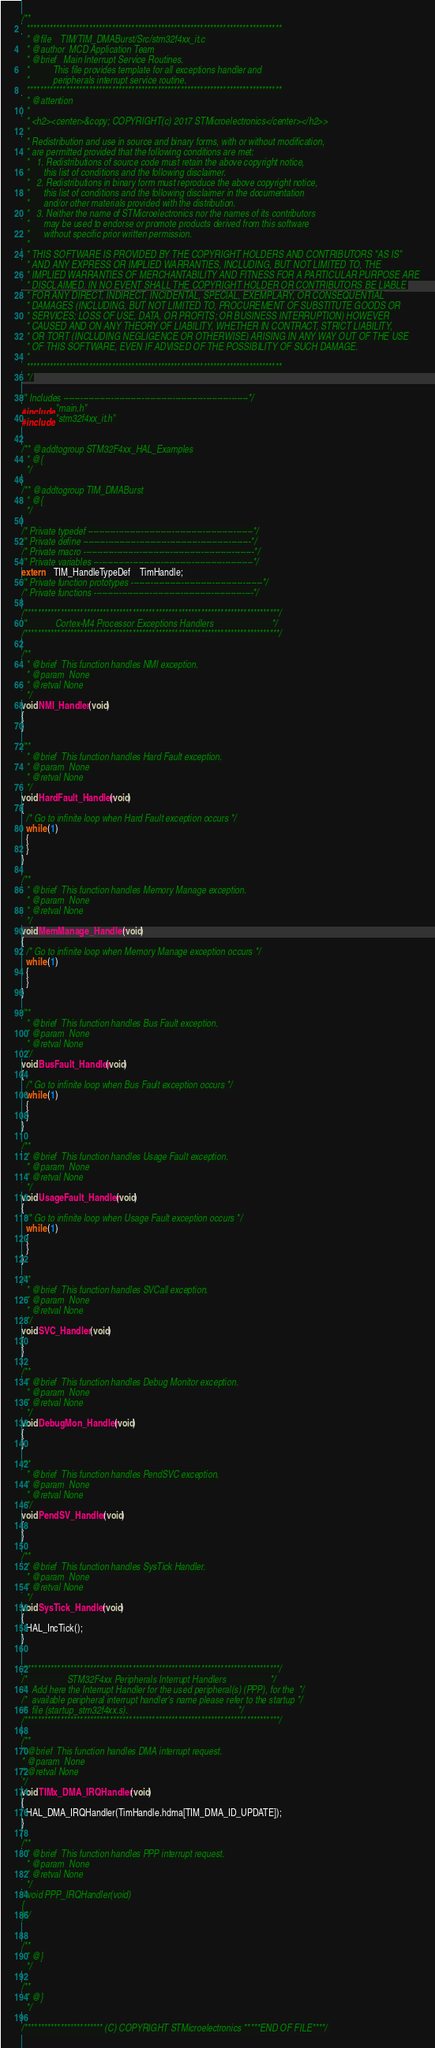Convert code to text. <code><loc_0><loc_0><loc_500><loc_500><_C_>/**
  ******************************************************************************
  * @file    TIM/TIM_DMABurst/Src/stm32f4xx_it.c  
  * @author  MCD Application Team
  * @brief   Main Interrupt Service Routines.
  *          This file provides template for all exceptions handler and 
  *          peripherals interrupt service routine.
  ******************************************************************************
  * @attention
  *
  * <h2><center>&copy; COPYRIGHT(c) 2017 STMicroelectronics</center></h2>>
  *
  * Redistribution and use in source and binary forms, with or without modification,
  * are permitted provided that the following conditions are met:
  *   1. Redistributions of source code must retain the above copyright notice,
  *      this list of conditions and the following disclaimer.
  *   2. Redistributions in binary form must reproduce the above copyright notice,
  *      this list of conditions and the following disclaimer in the documentation
  *      and/or other materials provided with the distribution.
  *   3. Neither the name of STMicroelectronics nor the names of its contributors
  *      may be used to endorse or promote products derived from this software
  *      without specific prior written permission.
  *
  * THIS SOFTWARE IS PROVIDED BY THE COPYRIGHT HOLDERS AND CONTRIBUTORS "AS IS"
  * AND ANY EXPRESS OR IMPLIED WARRANTIES, INCLUDING, BUT NOT LIMITED TO, THE
  * IMPLIED WARRANTIES OF MERCHANTABILITY AND FITNESS FOR A PARTICULAR PURPOSE ARE
  * DISCLAIMED. IN NO EVENT SHALL THE COPYRIGHT HOLDER OR CONTRIBUTORS BE LIABLE
  * FOR ANY DIRECT, INDIRECT, INCIDENTAL, SPECIAL, EXEMPLARY, OR CONSEQUENTIAL
  * DAMAGES (INCLUDING, BUT NOT LIMITED TO, PROCUREMENT OF SUBSTITUTE GOODS OR
  * SERVICES; LOSS OF USE, DATA, OR PROFITS; OR BUSINESS INTERRUPTION) HOWEVER
  * CAUSED AND ON ANY THEORY OF LIABILITY, WHETHER IN CONTRACT, STRICT LIABILITY,
  * OR TORT (INCLUDING NEGLIGENCE OR OTHERWISE) ARISING IN ANY WAY OUT OF THE USE
  * OF THIS SOFTWARE, EVEN IF ADVISED OF THE POSSIBILITY OF SUCH DAMAGE.
  *
  ******************************************************************************
  */

/* Includes ------------------------------------------------------------------*/
#include "main.h"
#include "stm32f4xx_it.h"
   

/** @addtogroup STM32F4xx_HAL_Examples
  * @{
  */

/** @addtogroup TIM_DMABurst
  * @{
  */

/* Private typedef -----------------------------------------------------------*/
/* Private define ------------------------------------------------------------*/
/* Private macro -------------------------------------------------------------*/
/* Private variables ---------------------------------------------------------*/
extern    TIM_HandleTypeDef    TimHandle;    
/* Private function prototypes -----------------------------------------------*/
/* Private functions ---------------------------------------------------------*/

/******************************************************************************/
/*            Cortex-M4 Processor Exceptions Handlers                         */
/******************************************************************************/

/**
  * @brief  This function handles NMI exception.
  * @param  None
  * @retval None
  */
void NMI_Handler(void)
{
}

/**
  * @brief  This function handles Hard Fault exception.
  * @param  None
  * @retval None
  */
void HardFault_Handler(void)
{
  /* Go to infinite loop when Hard Fault exception occurs */
  while (1)
  {
  }
}

/**
  * @brief  This function handles Memory Manage exception.
  * @param  None
  * @retval None
  */
void MemManage_Handler(void)
{
  /* Go to infinite loop when Memory Manage exception occurs */
  while (1)
  {
  }
}

/**
  * @brief  This function handles Bus Fault exception.
  * @param  None
  * @retval None
  */
void BusFault_Handler(void)
{
  /* Go to infinite loop when Bus Fault exception occurs */
  while (1)
  {
  }
}

/**
  * @brief  This function handles Usage Fault exception.
  * @param  None
  * @retval None
  */
void UsageFault_Handler(void)
{
  /* Go to infinite loop when Usage Fault exception occurs */
  while (1)
  {
  }
}

/**
  * @brief  This function handles SVCall exception.
  * @param  None
  * @retval None
  */
void SVC_Handler(void)
{
}

/**
  * @brief  This function handles Debug Monitor exception.
  * @param  None
  * @retval None
  */
void DebugMon_Handler(void)
{
}

/**
  * @brief  This function handles PendSVC exception.
  * @param  None
  * @retval None
  */
void PendSV_Handler(void)
{
}

/**
  * @brief  This function handles SysTick Handler.
  * @param  None
  * @retval None
  */
void SysTick_Handler(void)
{
  HAL_IncTick();
}


/******************************************************************************/
/*                 STM32F4xx Peripherals Interrupt Handlers                   */
/*  Add here the Interrupt Handler for the used peripheral(s) (PPP), for the  */
/*  available peripheral interrupt handler's name please refer to the startup */
/*  file (startup_stm32f4xx.s).                                               */
/******************************************************************************/

/**
* @brief  This function handles DMA interrupt request.
* @param  None
* @retval None
*/
void TIMx_DMA_IRQHandler(void)
{
  HAL_DMA_IRQHandler(TimHandle.hdma[TIM_DMA_ID_UPDATE]);
}

/**
  * @brief  This function handles PPP interrupt request.
  * @param  None
  * @retval None
  */
/*void PPP_IRQHandler(void)
{
}*/


/**
  * @}
  */ 

/**
  * @}
  */

/************************ (C) COPYRIGHT STMicroelectronics *****END OF FILE****/
</code> 